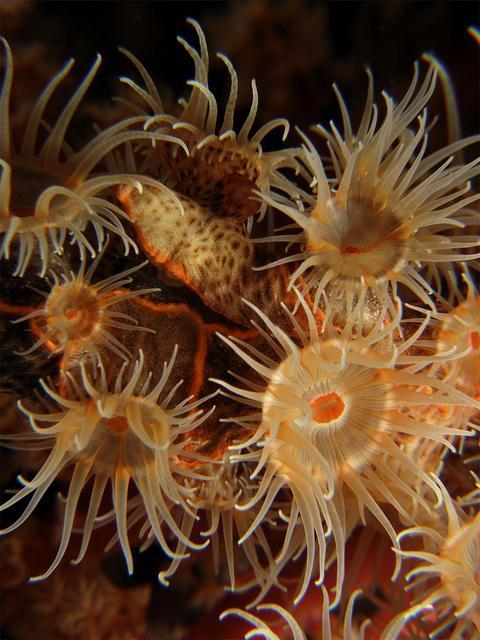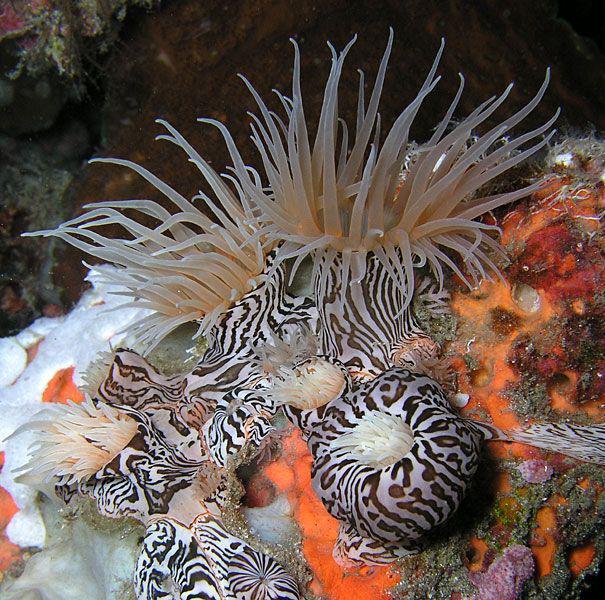The first image is the image on the left, the second image is the image on the right. Assess this claim about the two images: "The left image includes at least eight yellowish anemone that resemble flowers.". Correct or not? Answer yes or no. Yes. 